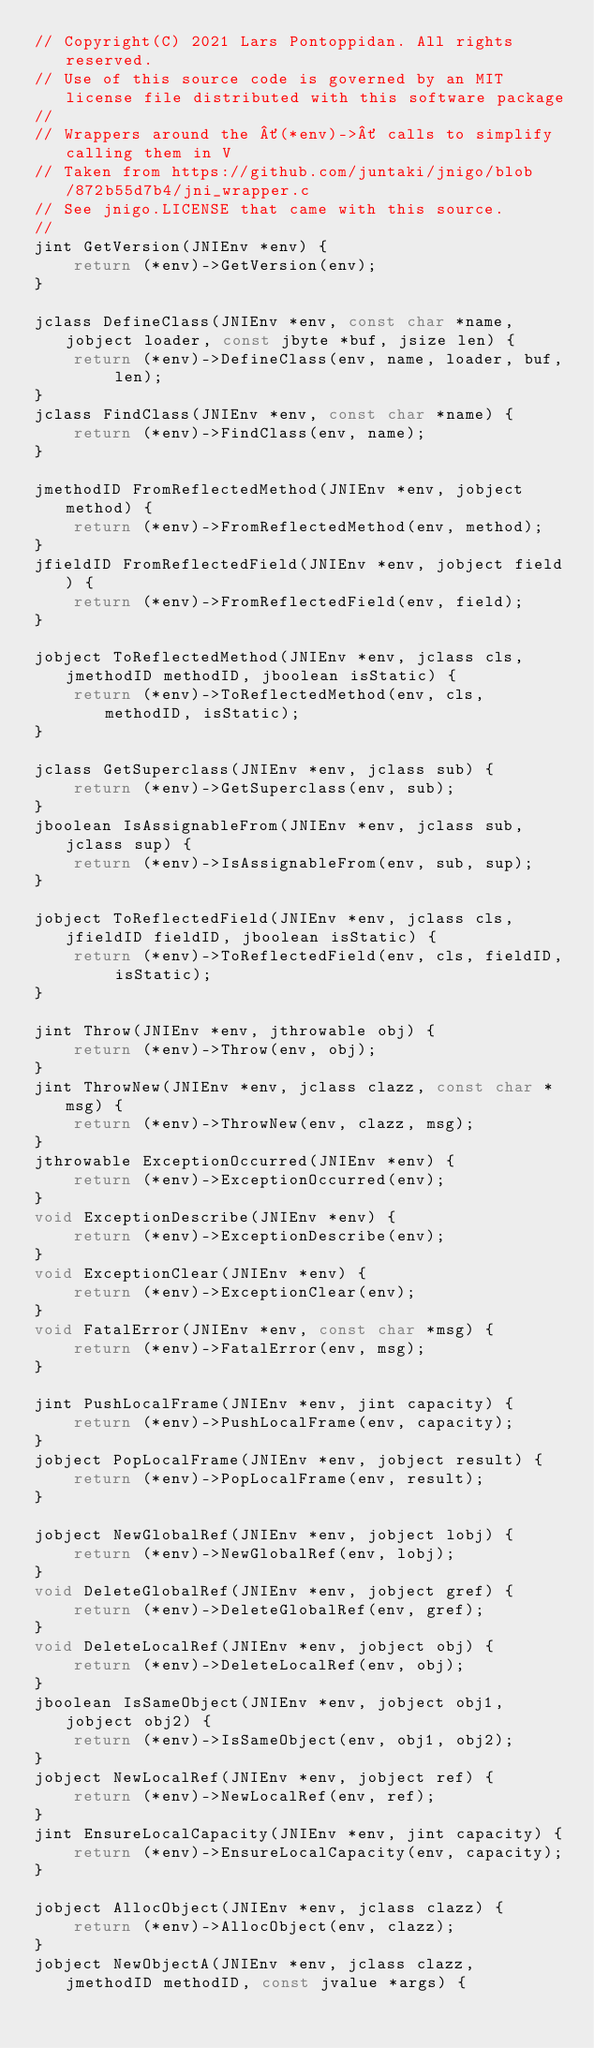Convert code to text. <code><loc_0><loc_0><loc_500><loc_500><_C_>// Copyright(C) 2021 Lars Pontoppidan. All rights reserved.
// Use of this source code is governed by an MIT license file distributed with this software package
//
// Wrappers around the ´(*env)->´ calls to simplify calling them in V
// Taken from https://github.com/juntaki/jnigo/blob/872b55d7b4/jni_wrapper.c
// See jnigo.LICENSE that came with this source.
//
jint GetVersion(JNIEnv *env) {
    return (*env)->GetVersion(env);
}

jclass DefineClass(JNIEnv *env, const char *name, jobject loader, const jbyte *buf, jsize len) {
    return (*env)->DefineClass(env, name, loader, buf, len);
}
jclass FindClass(JNIEnv *env, const char *name) {
    return (*env)->FindClass(env, name);
}

jmethodID FromReflectedMethod(JNIEnv *env, jobject method) {
    return (*env)->FromReflectedMethod(env, method);
}
jfieldID FromReflectedField(JNIEnv *env, jobject field) {
    return (*env)->FromReflectedField(env, field);
}

jobject ToReflectedMethod(JNIEnv *env, jclass cls, jmethodID methodID, jboolean isStatic) {
    return (*env)->ToReflectedMethod(env, cls, methodID, isStatic);
}

jclass GetSuperclass(JNIEnv *env, jclass sub) {
    return (*env)->GetSuperclass(env, sub);
}
jboolean IsAssignableFrom(JNIEnv *env, jclass sub, jclass sup) {
    return (*env)->IsAssignableFrom(env, sub, sup);
}

jobject ToReflectedField(JNIEnv *env, jclass cls, jfieldID fieldID, jboolean isStatic) {
    return (*env)->ToReflectedField(env, cls, fieldID, isStatic);
}

jint Throw(JNIEnv *env, jthrowable obj) {
    return (*env)->Throw(env, obj);
}
jint ThrowNew(JNIEnv *env, jclass clazz, const char *msg) {
    return (*env)->ThrowNew(env, clazz, msg);
}
jthrowable ExceptionOccurred(JNIEnv *env) {
    return (*env)->ExceptionOccurred(env);
}
void ExceptionDescribe(JNIEnv *env) {
    return (*env)->ExceptionDescribe(env);
}
void ExceptionClear(JNIEnv *env) {
    return (*env)->ExceptionClear(env);
}
void FatalError(JNIEnv *env, const char *msg) {
    return (*env)->FatalError(env, msg);
}

jint PushLocalFrame(JNIEnv *env, jint capacity) {
    return (*env)->PushLocalFrame(env, capacity);
}
jobject PopLocalFrame(JNIEnv *env, jobject result) {
    return (*env)->PopLocalFrame(env, result);
}

jobject NewGlobalRef(JNIEnv *env, jobject lobj) {
    return (*env)->NewGlobalRef(env, lobj);
}
void DeleteGlobalRef(JNIEnv *env, jobject gref) {
    return (*env)->DeleteGlobalRef(env, gref);
}
void DeleteLocalRef(JNIEnv *env, jobject obj) {
    return (*env)->DeleteLocalRef(env, obj);
}
jboolean IsSameObject(JNIEnv *env, jobject obj1, jobject obj2) {
    return (*env)->IsSameObject(env, obj1, obj2);
}
jobject NewLocalRef(JNIEnv *env, jobject ref) {
    return (*env)->NewLocalRef(env, ref);
}
jint EnsureLocalCapacity(JNIEnv *env, jint capacity) {
    return (*env)->EnsureLocalCapacity(env, capacity);
}

jobject AllocObject(JNIEnv *env, jclass clazz) {
    return (*env)->AllocObject(env, clazz);
}
jobject NewObjectA(JNIEnv *env, jclass clazz, jmethodID methodID, const jvalue *args) {</code> 